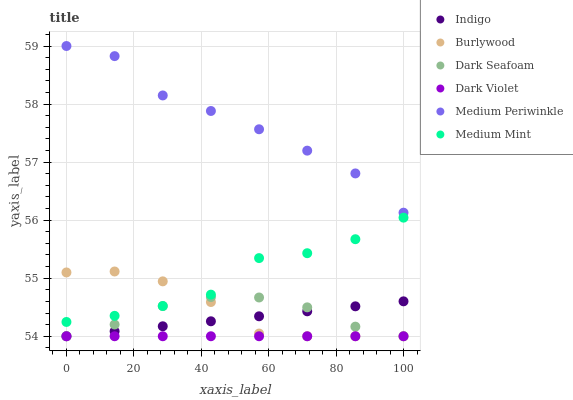Does Dark Violet have the minimum area under the curve?
Answer yes or no. Yes. Does Medium Periwinkle have the maximum area under the curve?
Answer yes or no. Yes. Does Indigo have the minimum area under the curve?
Answer yes or no. No. Does Indigo have the maximum area under the curve?
Answer yes or no. No. Is Dark Violet the smoothest?
Answer yes or no. Yes. Is Medium Mint the roughest?
Answer yes or no. Yes. Is Indigo the smoothest?
Answer yes or no. No. Is Indigo the roughest?
Answer yes or no. No. Does Indigo have the lowest value?
Answer yes or no. Yes. Does Medium Periwinkle have the lowest value?
Answer yes or no. No. Does Medium Periwinkle have the highest value?
Answer yes or no. Yes. Does Indigo have the highest value?
Answer yes or no. No. Is Burlywood less than Medium Periwinkle?
Answer yes or no. Yes. Is Medium Mint greater than Indigo?
Answer yes or no. Yes. Does Dark Seafoam intersect Dark Violet?
Answer yes or no. Yes. Is Dark Seafoam less than Dark Violet?
Answer yes or no. No. Is Dark Seafoam greater than Dark Violet?
Answer yes or no. No. Does Burlywood intersect Medium Periwinkle?
Answer yes or no. No. 